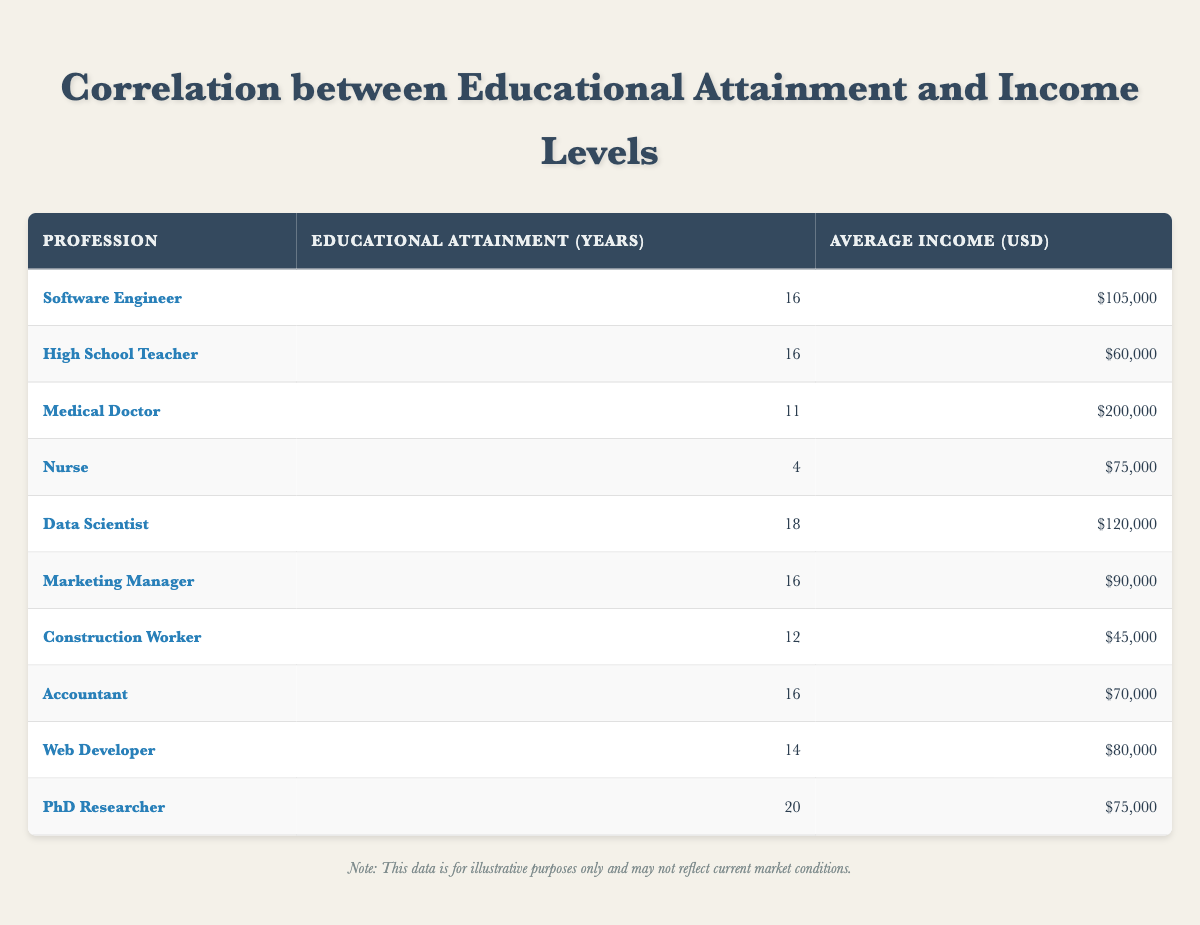What is the average income of a Software Engineer? Looking at the table, the average income for a Software Engineer is listed directly as $105,000.
Answer: $105,000 How many years of educational attainment do Data Scientists have? The table indicates that Data Scientists have 18 years of educational attainment.
Answer: 18 Which profession has the highest average income? By examining the average incomes listed, the Medical Doctor at $200,000 has the highest average income.
Answer: Medical Doctor What is the difference in average income between a High School Teacher and a Construction Worker? The average income for a High School Teacher is $60,000 and for a Construction Worker, it is $45,000. The difference is calculated as $60,000 - $45,000 = $15,000.
Answer: $15,000 Is the average income of a Nurse greater than that of an Accountant? The average income for a Nurse is $75,000, while for an Accountant, it is $70,000. Since $75,000 is greater than $70,000, the statement is true.
Answer: Yes What is the average educational attainment of the top three highest income professions? The top three highest income professions are Medical Doctor (11 years), Data Scientist (18 years), and Software Engineer (16 years). Summing these gives 11 + 18 + 16 = 45 years. The average for these three professions is 45 / 3 = 15 years.
Answer: 15 years Which profession has the lowest educational attainment and what is its average income? The profession with the lowest educational attainment is Nurse, with 4 years of education, and the average income for a Nurse is $75,000.
Answer: Nurse, $75,000 How many professions have an average income above $80,000? The professions with an average income above $80,000, based on the table, are Software Engineer ($105,000), Data Scientist ($120,000), and Medical Doctor ($200,000). This counts to three professions.
Answer: 3 What is the average of the average incomes for all listed professions? To find the average income, sum the listed average incomes: $105,000 + $60,000 + $200,000 + $75,000 + $120,000 + $90,000 + $45,000 + $70,000 + $80,000 + $75,000 = $1,010,000. There are 10 professions, so the average is $1,010,000 / 10 = $101,000.
Answer: $101,000 Is it true that all professions listed have an educational attainment of 16 years or more? Reviewing the educational attainment years, we see that the Nurse has only 4 years of educational attainment. Thus, the statement is false.
Answer: No 